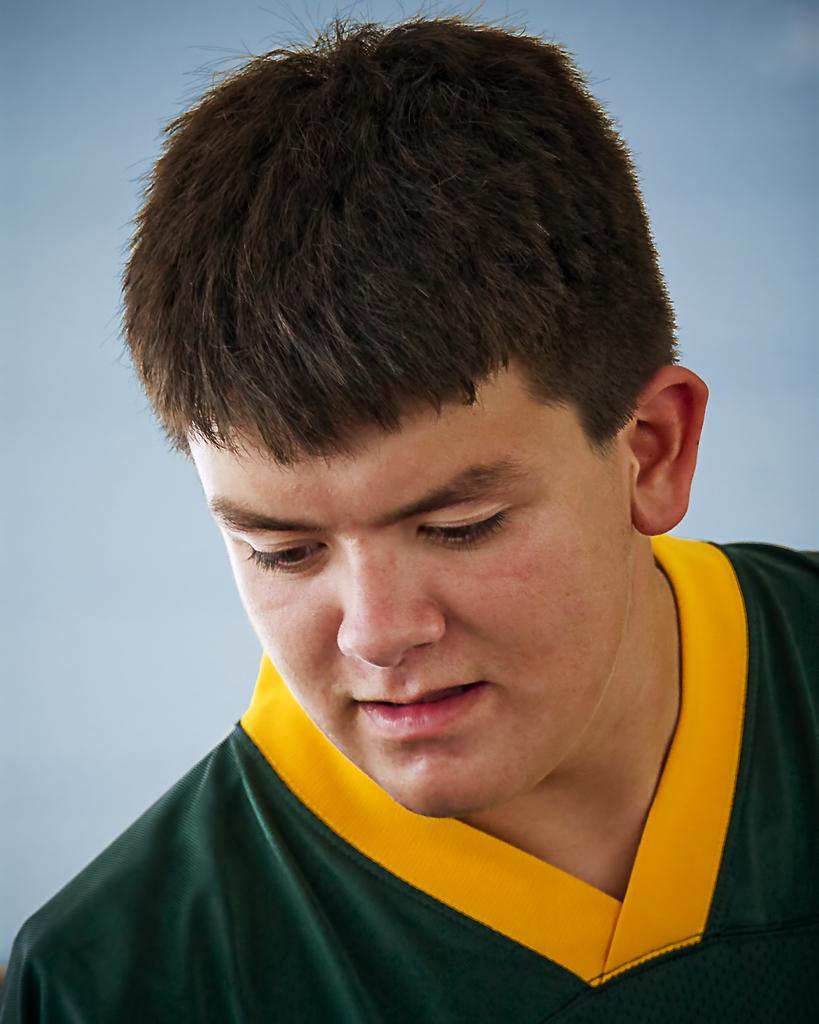How would you summarize this image in a sentence or two? In the picture I can see a man who is wearing a green and yellow color t-shirt. 